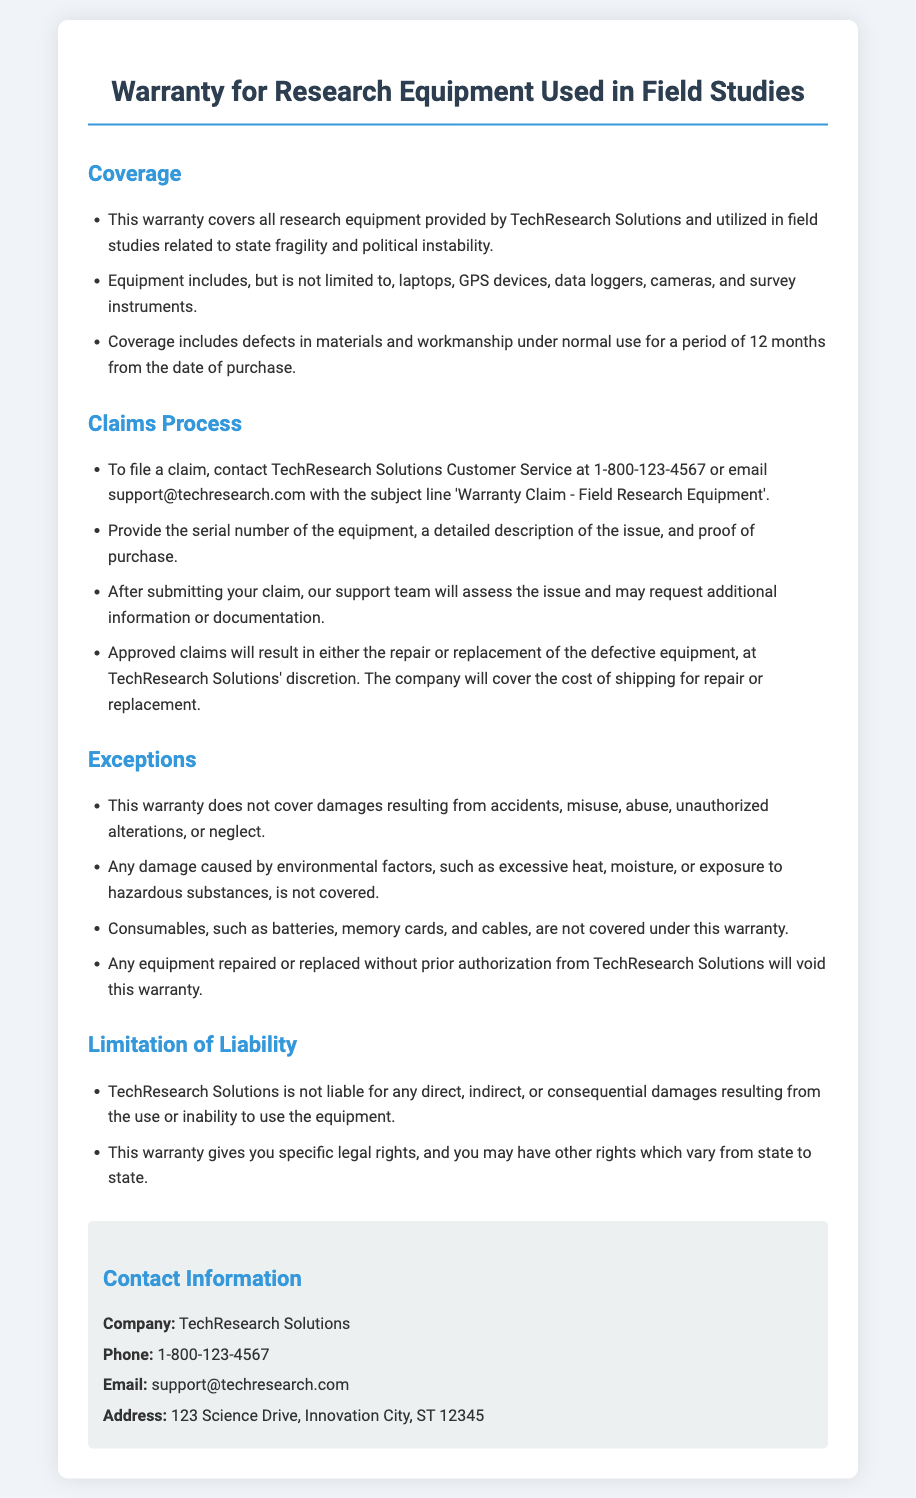What is the warranty coverage period? The coverage includes defects in materials and workmanship under normal use for a period of 12 months from the date of purchase.
Answer: 12 months What types of equipment are covered? The document specifies that equipment includes laptops, GPS devices, data loggers, cameras, and survey instruments.
Answer: Laptops, GPS devices, data loggers, cameras, and survey instruments What should you provide when filing a claim? You need to provide the serial number of the equipment, a detailed description of the issue, and proof of purchase.
Answer: Serial number, detailed description, proof of purchase What damages are not covered by the warranty? The warranty does not cover damages resulting from accidents, misuse, abuse, unauthorized alterations, or neglect.
Answer: Accidents, misuse, abuse, unauthorized alterations, neglect Who should be contacted for warranty claims? The document states that claims should be directed to TechResearch Solutions Customer Service either via phone or email.
Answer: TechResearch Solutions Customer Service What will happen to claims that are approved? Approved claims will result in either the repair or replacement of the defective equipment, at TechResearch Solutions' discretion.
Answer: Repair or replacement What is included under the exceptions section? Consumables like batteries, memory cards, and cables are specifically listed as not covered under the warranty.
Answer: Consumables What type of damages is TechResearch Solutions not liable for? TechResearch Solutions is not liable for any direct, indirect, or consequential damages resulting from the use or inability to use the equipment.
Answer: Direct, indirect, or consequential damages 